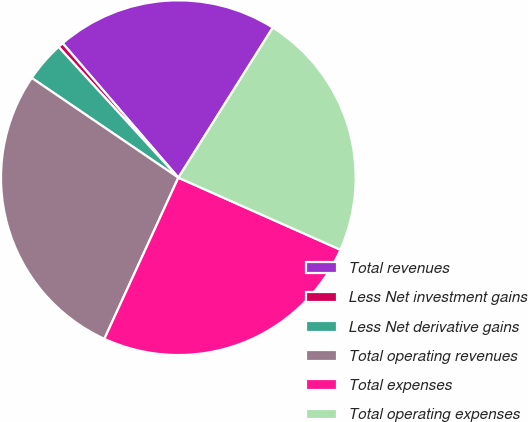Convert chart. <chart><loc_0><loc_0><loc_500><loc_500><pie_chart><fcel>Total revenues<fcel>Less Net investment gains<fcel>Less Net derivative gains<fcel>Total operating revenues<fcel>Total expenses<fcel>Total operating expenses<nl><fcel>20.25%<fcel>0.49%<fcel>3.69%<fcel>27.66%<fcel>25.19%<fcel>22.72%<nl></chart> 